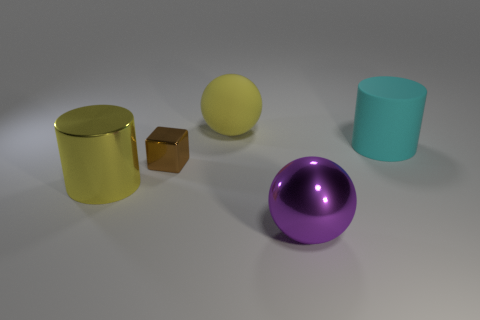How many cyan rubber balls are the same size as the purple object?
Give a very brief answer. 0. Does the big object in front of the yellow metallic thing have the same material as the large cylinder that is left of the small thing?
Provide a short and direct response. Yes. What material is the large sphere that is behind the cylinder that is in front of the big matte cylinder made of?
Make the answer very short. Rubber. What is the big yellow thing left of the large matte sphere made of?
Ensure brevity in your answer.  Metal. What number of large metal objects have the same shape as the small object?
Keep it short and to the point. 0. Is the tiny block the same color as the matte ball?
Provide a succinct answer. No. What is the large yellow object in front of the big object that is behind the large thing to the right of the large purple metallic sphere made of?
Offer a very short reply. Metal. There is a metallic cylinder; are there any big cyan rubber cylinders left of it?
Offer a terse response. No. What is the shape of the rubber object that is the same size as the cyan cylinder?
Ensure brevity in your answer.  Sphere. Does the brown block have the same material as the large yellow ball?
Make the answer very short. No. 